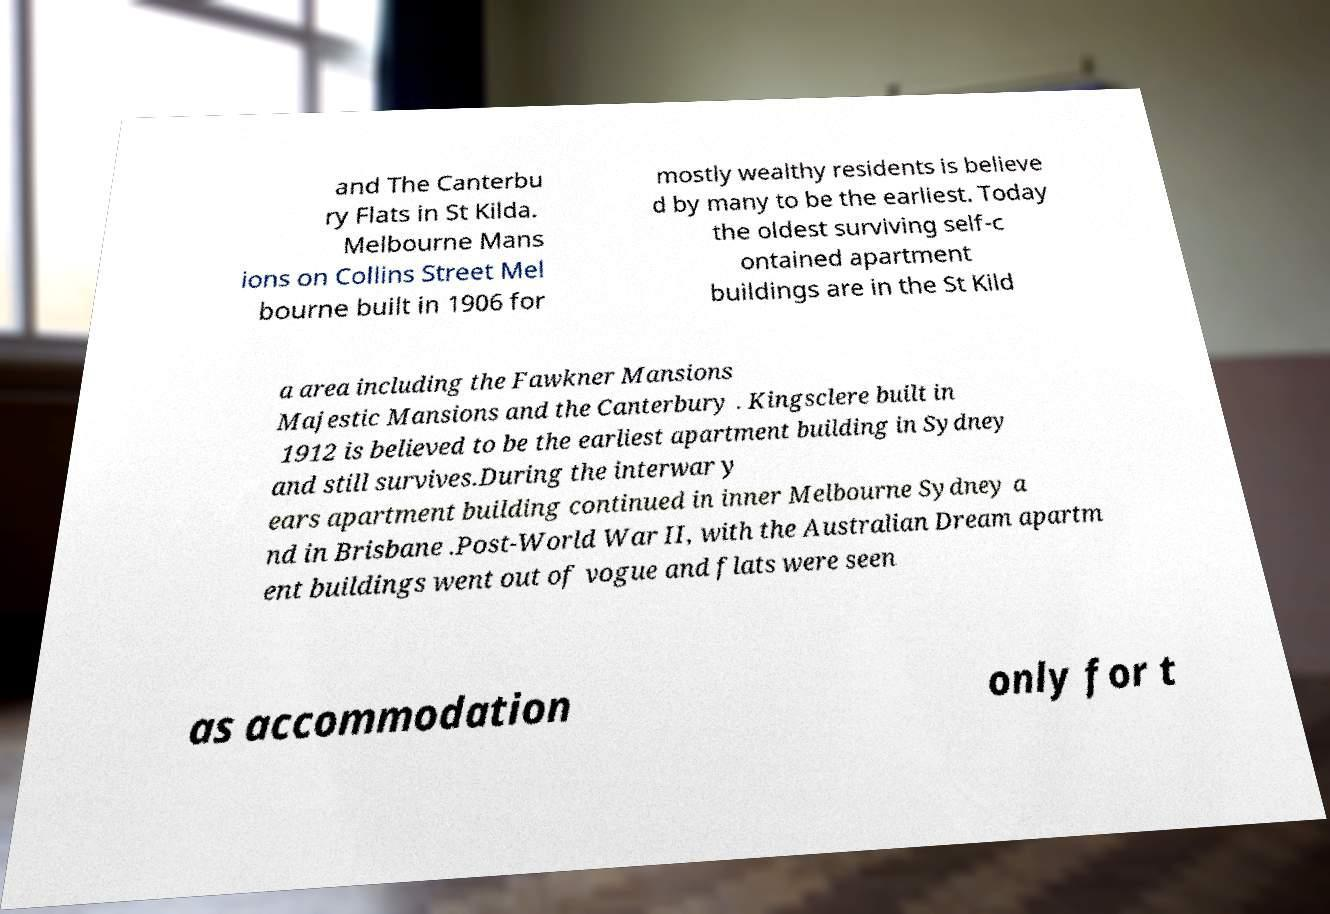Could you assist in decoding the text presented in this image and type it out clearly? and The Canterbu ry Flats in St Kilda. Melbourne Mans ions on Collins Street Mel bourne built in 1906 for mostly wealthy residents is believe d by many to be the earliest. Today the oldest surviving self-c ontained apartment buildings are in the St Kild a area including the Fawkner Mansions Majestic Mansions and the Canterbury . Kingsclere built in 1912 is believed to be the earliest apartment building in Sydney and still survives.During the interwar y ears apartment building continued in inner Melbourne Sydney a nd in Brisbane .Post-World War II, with the Australian Dream apartm ent buildings went out of vogue and flats were seen as accommodation only for t 